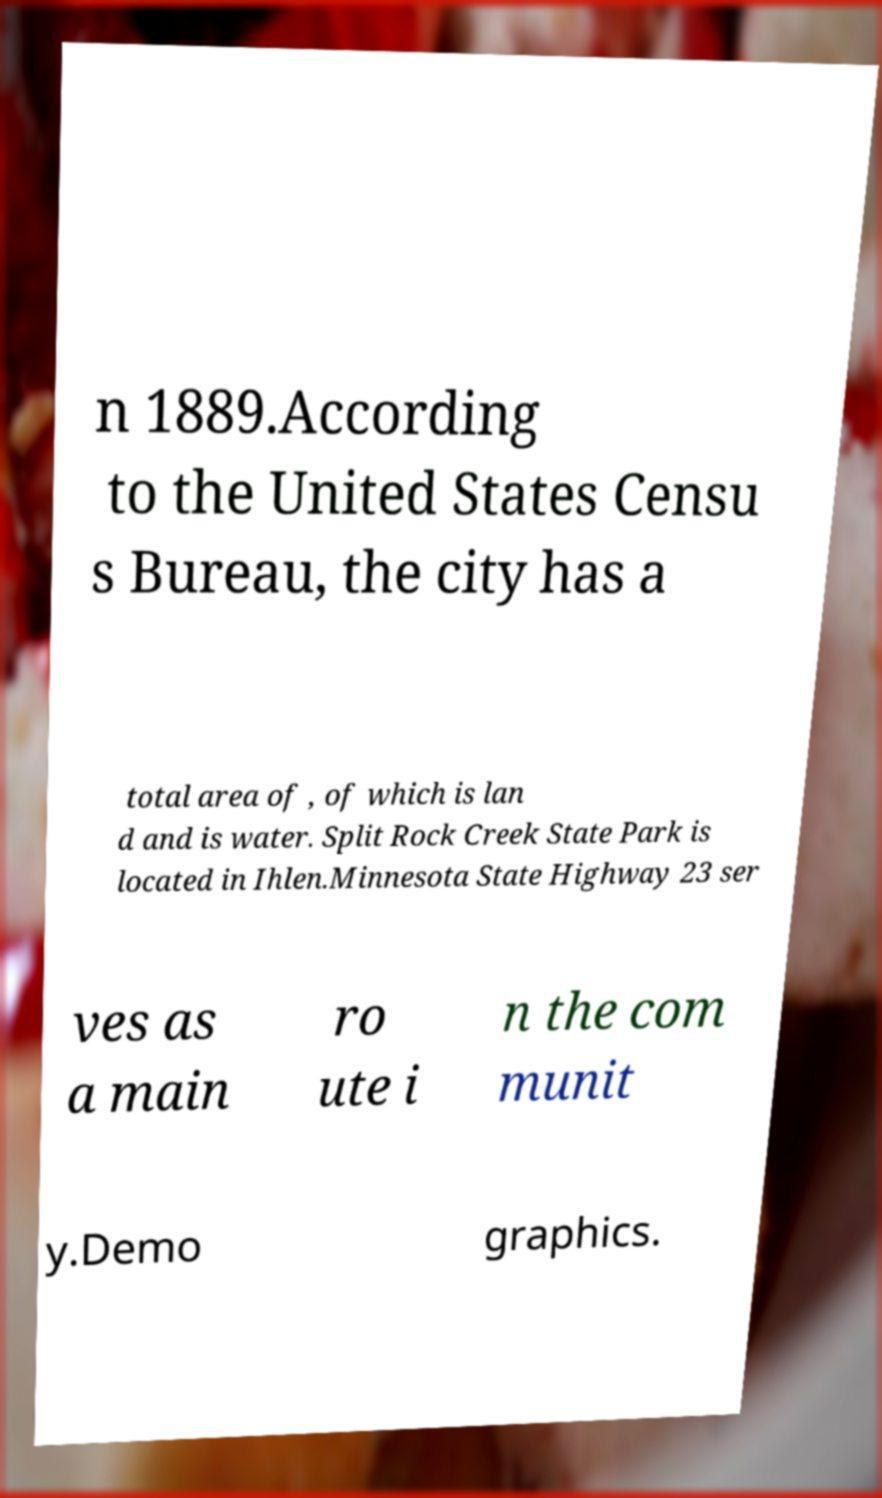For documentation purposes, I need the text within this image transcribed. Could you provide that? n 1889.According to the United States Censu s Bureau, the city has a total area of , of which is lan d and is water. Split Rock Creek State Park is located in Ihlen.Minnesota State Highway 23 ser ves as a main ro ute i n the com munit y.Demo graphics. 